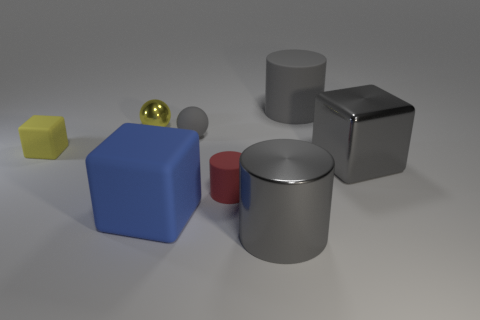Is the blue thing the same shape as the big gray rubber object?
Your answer should be very brief. No. There is a yellow object that is right of the tiny yellow matte block; how many metal spheres are behind it?
Your answer should be compact. 0. What is the material of the large blue thing that is the same shape as the yellow rubber thing?
Give a very brief answer. Rubber. There is a big shiny object in front of the tiny red thing; is it the same color as the tiny shiny object?
Provide a short and direct response. No. Do the red thing and the large gray cylinder in front of the small matte block have the same material?
Offer a terse response. No. What shape is the gray metal thing that is behind the large blue rubber cube?
Give a very brief answer. Cube. What number of other objects are there of the same material as the big blue cube?
Your response must be concise. 4. What size is the metallic sphere?
Keep it short and to the point. Small. What number of other things are there of the same color as the tiny block?
Provide a short and direct response. 1. There is a cube that is both on the right side of the yellow matte thing and to the left of the large gray rubber cylinder; what color is it?
Offer a very short reply. Blue. 